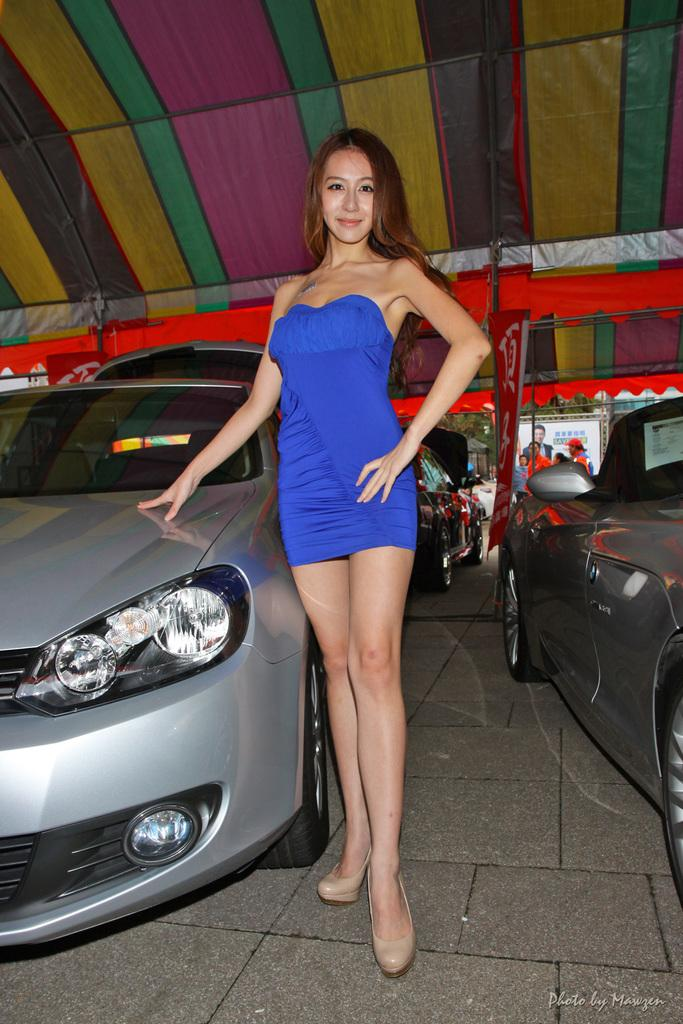Who is present in the image? There is a woman in the image. What is the woman standing beside? The woman is standing beside a car. What is the car under in the image? The car is under a tent. Are there any other cars in the image? Yes, there are other cars parked beside the car under the tent. Can you see any steam coming from the car in the image? There is no steam visible in the image. Is there a lake in the background of the image? There is no lake present in the image. 